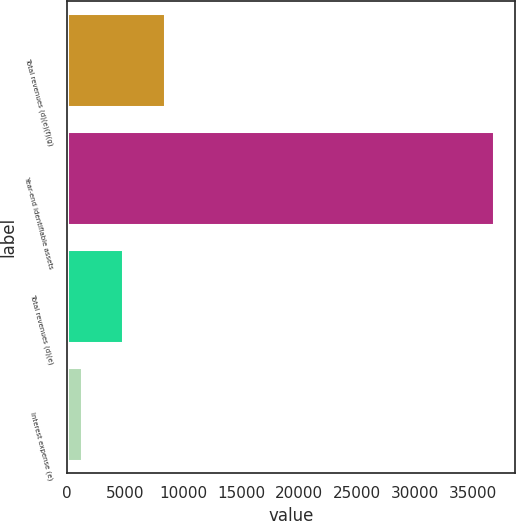<chart> <loc_0><loc_0><loc_500><loc_500><bar_chart><fcel>Total revenues (d)(e)(f)(g)<fcel>Year-end identifiable assets<fcel>Total revenues (d)(e)<fcel>Interest expense (e)<nl><fcel>8406.8<fcel>36822<fcel>4854.9<fcel>1303<nl></chart> 